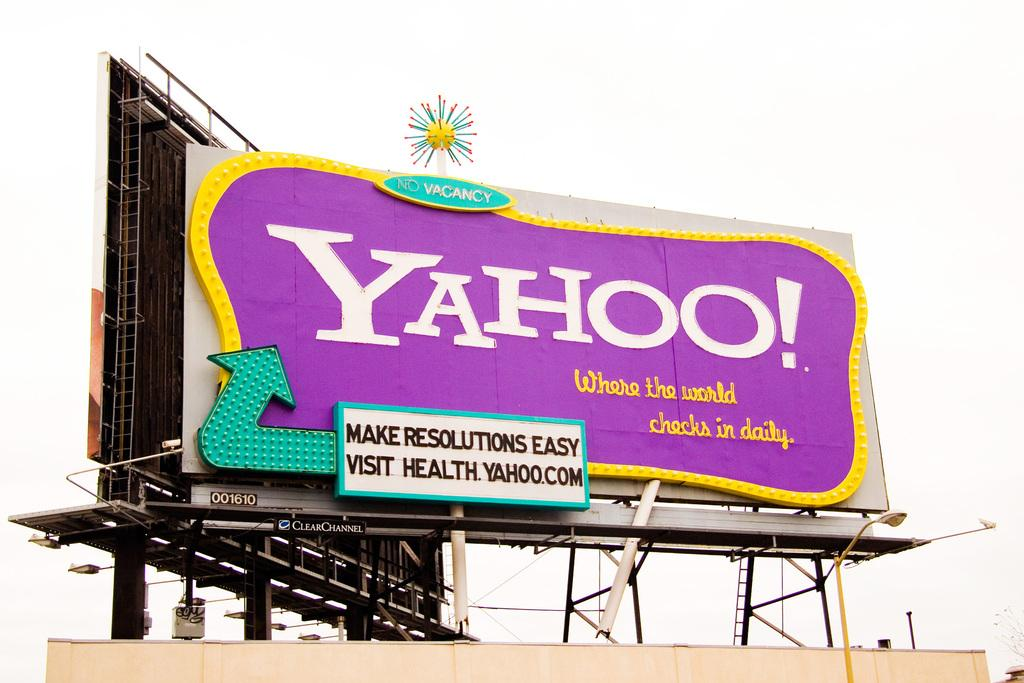<image>
Present a compact description of the photo's key features. A purple and yellow Yahoo billboard helps you make resolutions easy. 